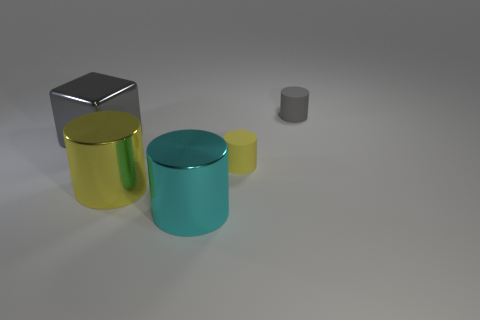How do the textures of the objects compare? The objects in the image exhibit varied textures. The yellow and blue cylinders have a shiny, reflective surface, suggesting a smooth texture like polished metal. In contrast, the gray cube appears to have a matte finish, absorbing more light and suggesting a rougher texture. 